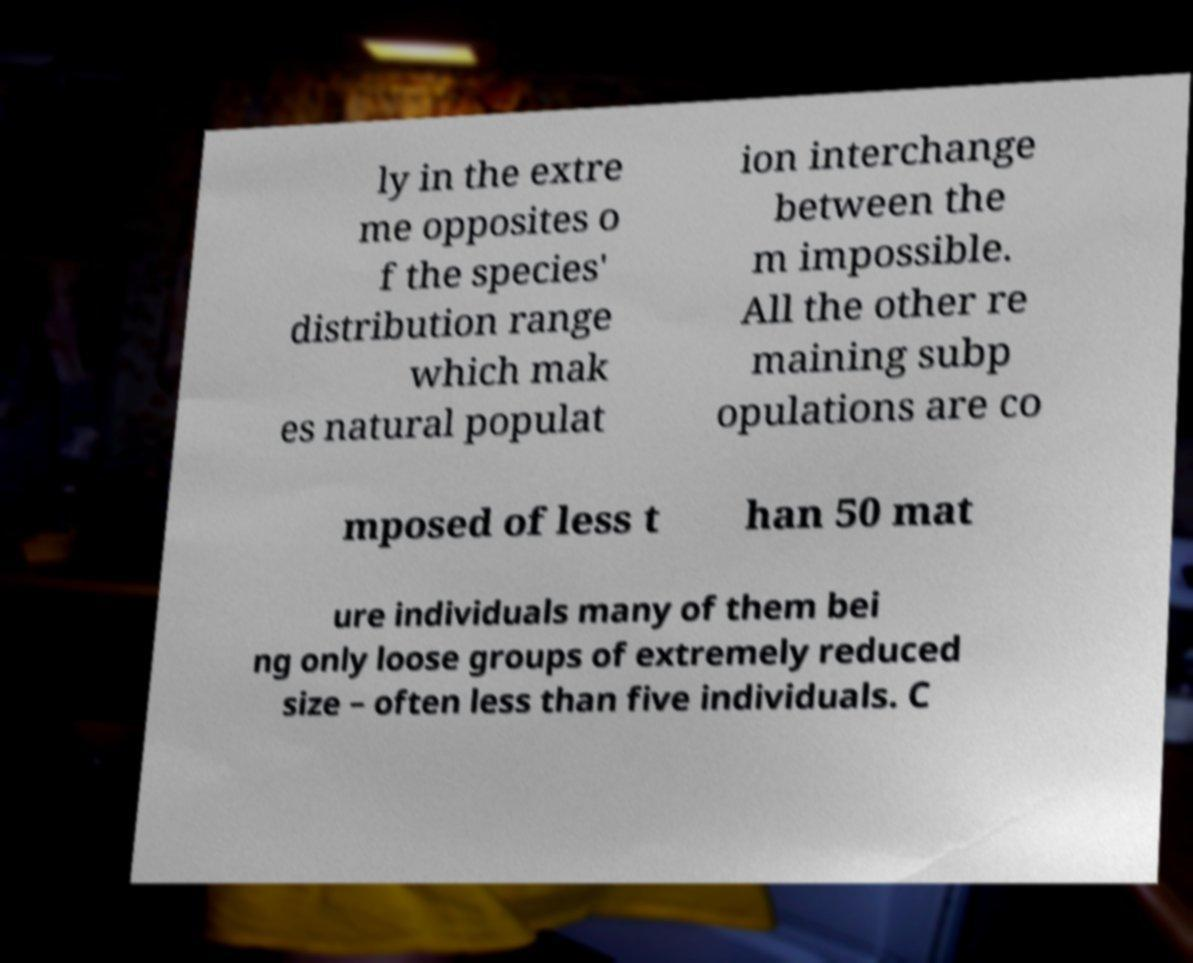What messages or text are displayed in this image? I need them in a readable, typed format. ly in the extre me opposites o f the species' distribution range which mak es natural populat ion interchange between the m impossible. All the other re maining subp opulations are co mposed of less t han 50 mat ure individuals many of them bei ng only loose groups of extremely reduced size – often less than five individuals. C 